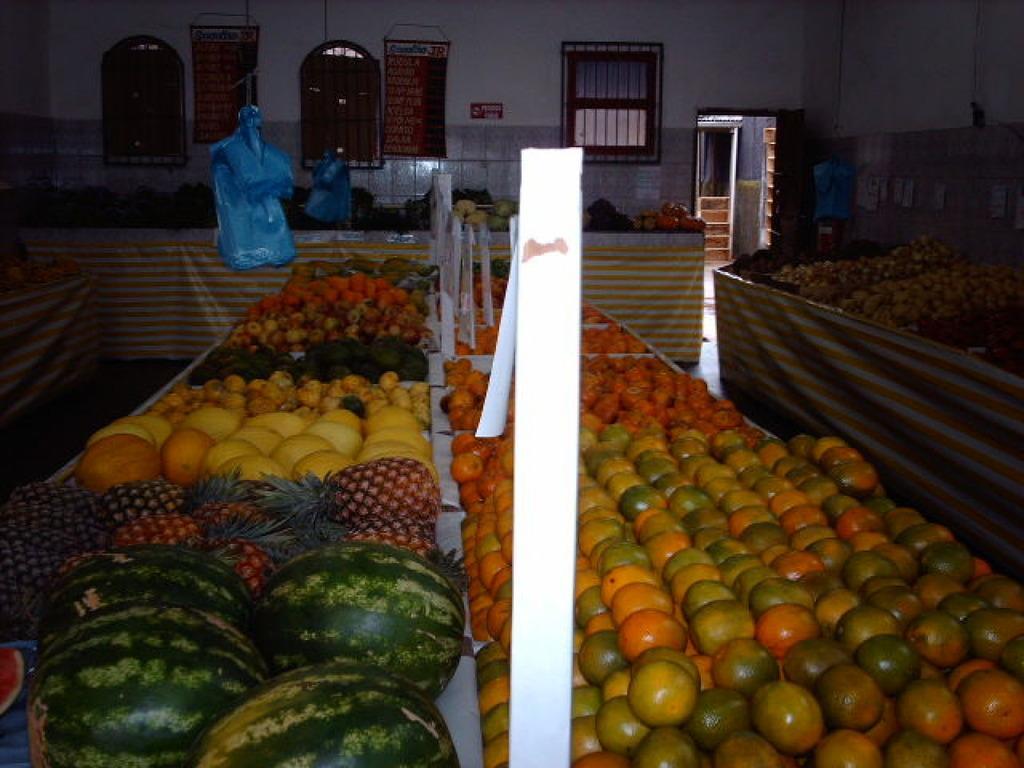How would you summarize this image in a sentence or two? In this image I can see few fruits and vegetables and they are in multi color. Background I can see few windows, stairs and the wall is in white color. 